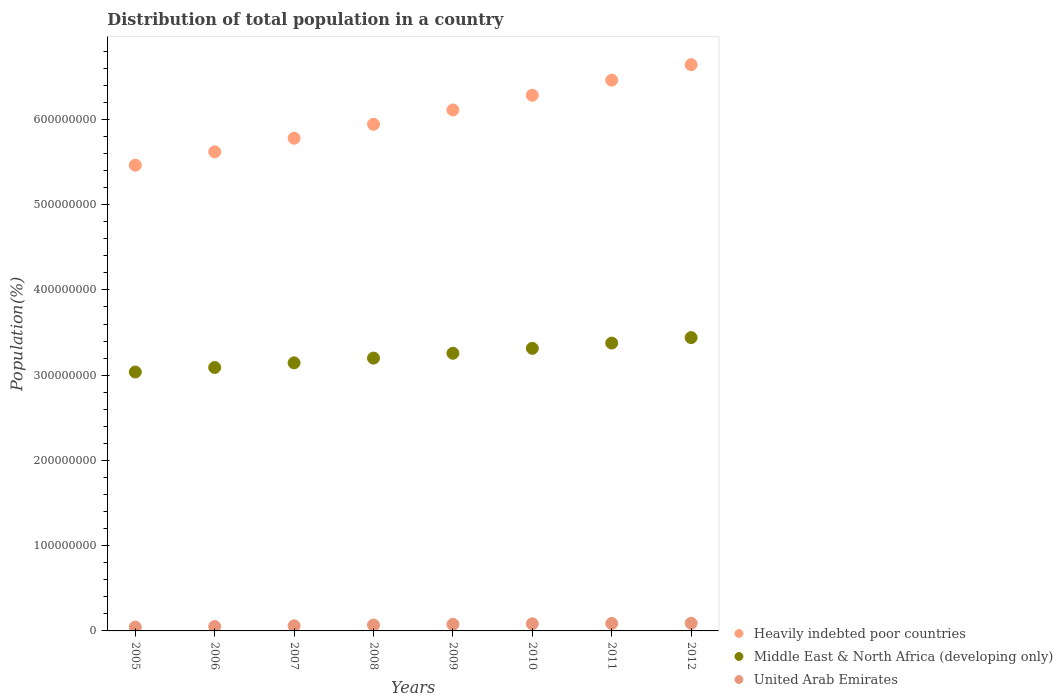What is the population of in Heavily indebted poor countries in 2005?
Provide a short and direct response. 5.46e+08. Across all years, what is the maximum population of in Middle East & North Africa (developing only)?
Give a very brief answer. 3.44e+08. Across all years, what is the minimum population of in Heavily indebted poor countries?
Provide a succinct answer. 5.46e+08. In which year was the population of in United Arab Emirates maximum?
Your response must be concise. 2012. What is the total population of in Heavily indebted poor countries in the graph?
Offer a terse response. 4.83e+09. What is the difference between the population of in United Arab Emirates in 2008 and that in 2011?
Give a very brief answer. -1.83e+06. What is the difference between the population of in Middle East & North Africa (developing only) in 2012 and the population of in United Arab Emirates in 2007?
Offer a very short reply. 3.38e+08. What is the average population of in Middle East & North Africa (developing only) per year?
Keep it short and to the point. 3.23e+08. In the year 2005, what is the difference between the population of in Heavily indebted poor countries and population of in United Arab Emirates?
Keep it short and to the point. 5.42e+08. In how many years, is the population of in Middle East & North Africa (developing only) greater than 220000000 %?
Ensure brevity in your answer.  8. What is the ratio of the population of in Heavily indebted poor countries in 2005 to that in 2009?
Provide a succinct answer. 0.89. What is the difference between the highest and the second highest population of in United Arab Emirates?
Keep it short and to the point. 2.18e+05. What is the difference between the highest and the lowest population of in Middle East & North Africa (developing only)?
Your response must be concise. 4.04e+07. In how many years, is the population of in Heavily indebted poor countries greater than the average population of in Heavily indebted poor countries taken over all years?
Make the answer very short. 4. Is the population of in United Arab Emirates strictly less than the population of in Heavily indebted poor countries over the years?
Keep it short and to the point. Yes. How many dotlines are there?
Keep it short and to the point. 3. How many years are there in the graph?
Your response must be concise. 8. What is the difference between two consecutive major ticks on the Y-axis?
Ensure brevity in your answer.  1.00e+08. Are the values on the major ticks of Y-axis written in scientific E-notation?
Give a very brief answer. No. Does the graph contain any zero values?
Keep it short and to the point. No. Does the graph contain grids?
Provide a succinct answer. No. Where does the legend appear in the graph?
Offer a very short reply. Bottom right. How many legend labels are there?
Offer a very short reply. 3. What is the title of the graph?
Your answer should be very brief. Distribution of total population in a country. What is the label or title of the X-axis?
Your answer should be compact. Years. What is the label or title of the Y-axis?
Your response must be concise. Population(%). What is the Population(%) of Heavily indebted poor countries in 2005?
Make the answer very short. 5.46e+08. What is the Population(%) in Middle East & North Africa (developing only) in 2005?
Your answer should be compact. 3.04e+08. What is the Population(%) in United Arab Emirates in 2005?
Your answer should be very brief. 4.48e+06. What is the Population(%) in Heavily indebted poor countries in 2006?
Give a very brief answer. 5.62e+08. What is the Population(%) in Middle East & North Africa (developing only) in 2006?
Your answer should be very brief. 3.09e+08. What is the Population(%) in United Arab Emirates in 2006?
Your response must be concise. 5.17e+06. What is the Population(%) in Heavily indebted poor countries in 2007?
Ensure brevity in your answer.  5.78e+08. What is the Population(%) of Middle East & North Africa (developing only) in 2007?
Provide a succinct answer. 3.14e+08. What is the Population(%) in United Arab Emirates in 2007?
Provide a short and direct response. 6.01e+06. What is the Population(%) of Heavily indebted poor countries in 2008?
Ensure brevity in your answer.  5.94e+08. What is the Population(%) in Middle East & North Africa (developing only) in 2008?
Your answer should be very brief. 3.20e+08. What is the Population(%) of United Arab Emirates in 2008?
Your response must be concise. 6.90e+06. What is the Population(%) in Heavily indebted poor countries in 2009?
Make the answer very short. 6.11e+08. What is the Population(%) of Middle East & North Africa (developing only) in 2009?
Provide a short and direct response. 3.26e+08. What is the Population(%) in United Arab Emirates in 2009?
Give a very brief answer. 7.71e+06. What is the Population(%) of Heavily indebted poor countries in 2010?
Offer a very short reply. 6.28e+08. What is the Population(%) in Middle East & North Africa (developing only) in 2010?
Offer a very short reply. 3.31e+08. What is the Population(%) of United Arab Emirates in 2010?
Your answer should be very brief. 8.33e+06. What is the Population(%) of Heavily indebted poor countries in 2011?
Offer a terse response. 6.46e+08. What is the Population(%) in Middle East & North Africa (developing only) in 2011?
Keep it short and to the point. 3.38e+08. What is the Population(%) of United Arab Emirates in 2011?
Your answer should be compact. 8.73e+06. What is the Population(%) in Heavily indebted poor countries in 2012?
Your response must be concise. 6.64e+08. What is the Population(%) in Middle East & North Africa (developing only) in 2012?
Your response must be concise. 3.44e+08. What is the Population(%) in United Arab Emirates in 2012?
Provide a succinct answer. 8.95e+06. Across all years, what is the maximum Population(%) of Heavily indebted poor countries?
Provide a succinct answer. 6.64e+08. Across all years, what is the maximum Population(%) in Middle East & North Africa (developing only)?
Provide a succinct answer. 3.44e+08. Across all years, what is the maximum Population(%) of United Arab Emirates?
Provide a succinct answer. 8.95e+06. Across all years, what is the minimum Population(%) in Heavily indebted poor countries?
Provide a succinct answer. 5.46e+08. Across all years, what is the minimum Population(%) of Middle East & North Africa (developing only)?
Provide a short and direct response. 3.04e+08. Across all years, what is the minimum Population(%) in United Arab Emirates?
Your response must be concise. 4.48e+06. What is the total Population(%) of Heavily indebted poor countries in the graph?
Keep it short and to the point. 4.83e+09. What is the total Population(%) of Middle East & North Africa (developing only) in the graph?
Offer a terse response. 2.59e+09. What is the total Population(%) of United Arab Emirates in the graph?
Your answer should be compact. 5.63e+07. What is the difference between the Population(%) in Heavily indebted poor countries in 2005 and that in 2006?
Make the answer very short. -1.56e+07. What is the difference between the Population(%) of Middle East & North Africa (developing only) in 2005 and that in 2006?
Offer a very short reply. -5.30e+06. What is the difference between the Population(%) in United Arab Emirates in 2005 and that in 2006?
Ensure brevity in your answer.  -6.89e+05. What is the difference between the Population(%) in Heavily indebted poor countries in 2005 and that in 2007?
Ensure brevity in your answer.  -3.16e+07. What is the difference between the Population(%) of Middle East & North Africa (developing only) in 2005 and that in 2007?
Your answer should be compact. -1.07e+07. What is the difference between the Population(%) of United Arab Emirates in 2005 and that in 2007?
Offer a very short reply. -1.53e+06. What is the difference between the Population(%) in Heavily indebted poor countries in 2005 and that in 2008?
Provide a succinct answer. -4.80e+07. What is the difference between the Population(%) in Middle East & North Africa (developing only) in 2005 and that in 2008?
Your answer should be very brief. -1.63e+07. What is the difference between the Population(%) in United Arab Emirates in 2005 and that in 2008?
Offer a very short reply. -2.42e+06. What is the difference between the Population(%) in Heavily indebted poor countries in 2005 and that in 2009?
Offer a very short reply. -6.48e+07. What is the difference between the Population(%) of Middle East & North Africa (developing only) in 2005 and that in 2009?
Offer a very short reply. -2.20e+07. What is the difference between the Population(%) of United Arab Emirates in 2005 and that in 2009?
Provide a succinct answer. -3.22e+06. What is the difference between the Population(%) of Heavily indebted poor countries in 2005 and that in 2010?
Make the answer very short. -8.20e+07. What is the difference between the Population(%) in Middle East & North Africa (developing only) in 2005 and that in 2010?
Make the answer very short. -2.78e+07. What is the difference between the Population(%) of United Arab Emirates in 2005 and that in 2010?
Keep it short and to the point. -3.85e+06. What is the difference between the Population(%) in Heavily indebted poor countries in 2005 and that in 2011?
Offer a terse response. -9.97e+07. What is the difference between the Population(%) in Middle East & North Africa (developing only) in 2005 and that in 2011?
Your answer should be very brief. -3.39e+07. What is the difference between the Population(%) of United Arab Emirates in 2005 and that in 2011?
Your answer should be very brief. -4.25e+06. What is the difference between the Population(%) in Heavily indebted poor countries in 2005 and that in 2012?
Ensure brevity in your answer.  -1.18e+08. What is the difference between the Population(%) of Middle East & North Africa (developing only) in 2005 and that in 2012?
Keep it short and to the point. -4.04e+07. What is the difference between the Population(%) in United Arab Emirates in 2005 and that in 2012?
Keep it short and to the point. -4.47e+06. What is the difference between the Population(%) in Heavily indebted poor countries in 2006 and that in 2007?
Your answer should be compact. -1.60e+07. What is the difference between the Population(%) of Middle East & North Africa (developing only) in 2006 and that in 2007?
Give a very brief answer. -5.43e+06. What is the difference between the Population(%) of United Arab Emirates in 2006 and that in 2007?
Offer a very short reply. -8.39e+05. What is the difference between the Population(%) in Heavily indebted poor countries in 2006 and that in 2008?
Offer a terse response. -3.24e+07. What is the difference between the Population(%) in Middle East & North Africa (developing only) in 2006 and that in 2008?
Offer a very short reply. -1.10e+07. What is the difference between the Population(%) of United Arab Emirates in 2006 and that in 2008?
Make the answer very short. -1.73e+06. What is the difference between the Population(%) in Heavily indebted poor countries in 2006 and that in 2009?
Give a very brief answer. -4.92e+07. What is the difference between the Population(%) in Middle East & North Africa (developing only) in 2006 and that in 2009?
Give a very brief answer. -1.67e+07. What is the difference between the Population(%) of United Arab Emirates in 2006 and that in 2009?
Provide a short and direct response. -2.53e+06. What is the difference between the Population(%) in Heavily indebted poor countries in 2006 and that in 2010?
Give a very brief answer. -6.64e+07. What is the difference between the Population(%) in Middle East & North Africa (developing only) in 2006 and that in 2010?
Make the answer very short. -2.25e+07. What is the difference between the Population(%) of United Arab Emirates in 2006 and that in 2010?
Make the answer very short. -3.16e+06. What is the difference between the Population(%) in Heavily indebted poor countries in 2006 and that in 2011?
Your answer should be very brief. -8.41e+07. What is the difference between the Population(%) in Middle East & North Africa (developing only) in 2006 and that in 2011?
Provide a succinct answer. -2.86e+07. What is the difference between the Population(%) of United Arab Emirates in 2006 and that in 2011?
Ensure brevity in your answer.  -3.56e+06. What is the difference between the Population(%) of Heavily indebted poor countries in 2006 and that in 2012?
Provide a short and direct response. -1.02e+08. What is the difference between the Population(%) of Middle East & North Africa (developing only) in 2006 and that in 2012?
Give a very brief answer. -3.51e+07. What is the difference between the Population(%) in United Arab Emirates in 2006 and that in 2012?
Ensure brevity in your answer.  -3.78e+06. What is the difference between the Population(%) in Heavily indebted poor countries in 2007 and that in 2008?
Give a very brief answer. -1.64e+07. What is the difference between the Population(%) in Middle East & North Africa (developing only) in 2007 and that in 2008?
Provide a short and direct response. -5.57e+06. What is the difference between the Population(%) of United Arab Emirates in 2007 and that in 2008?
Your answer should be very brief. -8.90e+05. What is the difference between the Population(%) of Heavily indebted poor countries in 2007 and that in 2009?
Provide a succinct answer. -3.32e+07. What is the difference between the Population(%) of Middle East & North Africa (developing only) in 2007 and that in 2009?
Make the answer very short. -1.13e+07. What is the difference between the Population(%) of United Arab Emirates in 2007 and that in 2009?
Provide a succinct answer. -1.70e+06. What is the difference between the Population(%) in Heavily indebted poor countries in 2007 and that in 2010?
Keep it short and to the point. -5.04e+07. What is the difference between the Population(%) in Middle East & North Africa (developing only) in 2007 and that in 2010?
Give a very brief answer. -1.70e+07. What is the difference between the Population(%) of United Arab Emirates in 2007 and that in 2010?
Offer a very short reply. -2.32e+06. What is the difference between the Population(%) of Heavily indebted poor countries in 2007 and that in 2011?
Offer a very short reply. -6.81e+07. What is the difference between the Population(%) of Middle East & North Africa (developing only) in 2007 and that in 2011?
Keep it short and to the point. -2.32e+07. What is the difference between the Population(%) in United Arab Emirates in 2007 and that in 2011?
Offer a terse response. -2.72e+06. What is the difference between the Population(%) of Heavily indebted poor countries in 2007 and that in 2012?
Your answer should be very brief. -8.62e+07. What is the difference between the Population(%) of Middle East & North Africa (developing only) in 2007 and that in 2012?
Provide a short and direct response. -2.96e+07. What is the difference between the Population(%) in United Arab Emirates in 2007 and that in 2012?
Keep it short and to the point. -2.94e+06. What is the difference between the Population(%) in Heavily indebted poor countries in 2008 and that in 2009?
Your answer should be very brief. -1.68e+07. What is the difference between the Population(%) in Middle East & North Africa (developing only) in 2008 and that in 2009?
Provide a short and direct response. -5.68e+06. What is the difference between the Population(%) in United Arab Emirates in 2008 and that in 2009?
Provide a succinct answer. -8.05e+05. What is the difference between the Population(%) of Heavily indebted poor countries in 2008 and that in 2010?
Your answer should be very brief. -3.40e+07. What is the difference between the Population(%) in Middle East & North Africa (developing only) in 2008 and that in 2010?
Ensure brevity in your answer.  -1.15e+07. What is the difference between the Population(%) of United Arab Emirates in 2008 and that in 2010?
Keep it short and to the point. -1.43e+06. What is the difference between the Population(%) in Heavily indebted poor countries in 2008 and that in 2011?
Provide a short and direct response. -5.17e+07. What is the difference between the Population(%) in Middle East & North Africa (developing only) in 2008 and that in 2011?
Your answer should be very brief. -1.76e+07. What is the difference between the Population(%) in United Arab Emirates in 2008 and that in 2011?
Provide a short and direct response. -1.83e+06. What is the difference between the Population(%) of Heavily indebted poor countries in 2008 and that in 2012?
Your answer should be very brief. -6.99e+07. What is the difference between the Population(%) in Middle East & North Africa (developing only) in 2008 and that in 2012?
Your answer should be compact. -2.40e+07. What is the difference between the Population(%) of United Arab Emirates in 2008 and that in 2012?
Your answer should be compact. -2.05e+06. What is the difference between the Population(%) of Heavily indebted poor countries in 2009 and that in 2010?
Provide a succinct answer. -1.72e+07. What is the difference between the Population(%) of Middle East & North Africa (developing only) in 2009 and that in 2010?
Provide a short and direct response. -5.77e+06. What is the difference between the Population(%) of United Arab Emirates in 2009 and that in 2010?
Make the answer very short. -6.24e+05. What is the difference between the Population(%) of Heavily indebted poor countries in 2009 and that in 2011?
Your response must be concise. -3.49e+07. What is the difference between the Population(%) of Middle East & North Africa (developing only) in 2009 and that in 2011?
Your response must be concise. -1.19e+07. What is the difference between the Population(%) of United Arab Emirates in 2009 and that in 2011?
Offer a terse response. -1.03e+06. What is the difference between the Population(%) of Heavily indebted poor countries in 2009 and that in 2012?
Provide a succinct answer. -5.31e+07. What is the difference between the Population(%) in Middle East & North Africa (developing only) in 2009 and that in 2012?
Ensure brevity in your answer.  -1.84e+07. What is the difference between the Population(%) of United Arab Emirates in 2009 and that in 2012?
Give a very brief answer. -1.25e+06. What is the difference between the Population(%) in Heavily indebted poor countries in 2010 and that in 2011?
Provide a short and direct response. -1.77e+07. What is the difference between the Population(%) in Middle East & North Africa (developing only) in 2010 and that in 2011?
Ensure brevity in your answer.  -6.18e+06. What is the difference between the Population(%) in United Arab Emirates in 2010 and that in 2011?
Make the answer very short. -4.05e+05. What is the difference between the Population(%) in Heavily indebted poor countries in 2010 and that in 2012?
Your answer should be very brief. -3.58e+07. What is the difference between the Population(%) in Middle East & North Africa (developing only) in 2010 and that in 2012?
Your answer should be very brief. -1.26e+07. What is the difference between the Population(%) of United Arab Emirates in 2010 and that in 2012?
Offer a very short reply. -6.23e+05. What is the difference between the Population(%) of Heavily indebted poor countries in 2011 and that in 2012?
Give a very brief answer. -1.81e+07. What is the difference between the Population(%) of Middle East & North Africa (developing only) in 2011 and that in 2012?
Offer a very short reply. -6.41e+06. What is the difference between the Population(%) in United Arab Emirates in 2011 and that in 2012?
Keep it short and to the point. -2.18e+05. What is the difference between the Population(%) of Heavily indebted poor countries in 2005 and the Population(%) of Middle East & North Africa (developing only) in 2006?
Make the answer very short. 2.37e+08. What is the difference between the Population(%) of Heavily indebted poor countries in 2005 and the Population(%) of United Arab Emirates in 2006?
Your response must be concise. 5.41e+08. What is the difference between the Population(%) of Middle East & North Africa (developing only) in 2005 and the Population(%) of United Arab Emirates in 2006?
Give a very brief answer. 2.99e+08. What is the difference between the Population(%) in Heavily indebted poor countries in 2005 and the Population(%) in Middle East & North Africa (developing only) in 2007?
Offer a terse response. 2.32e+08. What is the difference between the Population(%) of Heavily indebted poor countries in 2005 and the Population(%) of United Arab Emirates in 2007?
Your answer should be very brief. 5.40e+08. What is the difference between the Population(%) of Middle East & North Africa (developing only) in 2005 and the Population(%) of United Arab Emirates in 2007?
Offer a terse response. 2.98e+08. What is the difference between the Population(%) in Heavily indebted poor countries in 2005 and the Population(%) in Middle East & North Africa (developing only) in 2008?
Ensure brevity in your answer.  2.26e+08. What is the difference between the Population(%) in Heavily indebted poor countries in 2005 and the Population(%) in United Arab Emirates in 2008?
Give a very brief answer. 5.39e+08. What is the difference between the Population(%) of Middle East & North Africa (developing only) in 2005 and the Population(%) of United Arab Emirates in 2008?
Ensure brevity in your answer.  2.97e+08. What is the difference between the Population(%) of Heavily indebted poor countries in 2005 and the Population(%) of Middle East & North Africa (developing only) in 2009?
Offer a very short reply. 2.21e+08. What is the difference between the Population(%) in Heavily indebted poor countries in 2005 and the Population(%) in United Arab Emirates in 2009?
Your answer should be very brief. 5.39e+08. What is the difference between the Population(%) of Middle East & North Africa (developing only) in 2005 and the Population(%) of United Arab Emirates in 2009?
Give a very brief answer. 2.96e+08. What is the difference between the Population(%) in Heavily indebted poor countries in 2005 and the Population(%) in Middle East & North Africa (developing only) in 2010?
Make the answer very short. 2.15e+08. What is the difference between the Population(%) of Heavily indebted poor countries in 2005 and the Population(%) of United Arab Emirates in 2010?
Provide a short and direct response. 5.38e+08. What is the difference between the Population(%) in Middle East & North Africa (developing only) in 2005 and the Population(%) in United Arab Emirates in 2010?
Make the answer very short. 2.95e+08. What is the difference between the Population(%) in Heavily indebted poor countries in 2005 and the Population(%) in Middle East & North Africa (developing only) in 2011?
Your answer should be very brief. 2.09e+08. What is the difference between the Population(%) of Heavily indebted poor countries in 2005 and the Population(%) of United Arab Emirates in 2011?
Your response must be concise. 5.38e+08. What is the difference between the Population(%) in Middle East & North Africa (developing only) in 2005 and the Population(%) in United Arab Emirates in 2011?
Your response must be concise. 2.95e+08. What is the difference between the Population(%) of Heavily indebted poor countries in 2005 and the Population(%) of Middle East & North Africa (developing only) in 2012?
Provide a succinct answer. 2.02e+08. What is the difference between the Population(%) of Heavily indebted poor countries in 2005 and the Population(%) of United Arab Emirates in 2012?
Your response must be concise. 5.37e+08. What is the difference between the Population(%) in Middle East & North Africa (developing only) in 2005 and the Population(%) in United Arab Emirates in 2012?
Your answer should be compact. 2.95e+08. What is the difference between the Population(%) in Heavily indebted poor countries in 2006 and the Population(%) in Middle East & North Africa (developing only) in 2007?
Keep it short and to the point. 2.48e+08. What is the difference between the Population(%) of Heavily indebted poor countries in 2006 and the Population(%) of United Arab Emirates in 2007?
Your answer should be very brief. 5.56e+08. What is the difference between the Population(%) of Middle East & North Africa (developing only) in 2006 and the Population(%) of United Arab Emirates in 2007?
Provide a succinct answer. 3.03e+08. What is the difference between the Population(%) of Heavily indebted poor countries in 2006 and the Population(%) of Middle East & North Africa (developing only) in 2008?
Your answer should be very brief. 2.42e+08. What is the difference between the Population(%) in Heavily indebted poor countries in 2006 and the Population(%) in United Arab Emirates in 2008?
Offer a very short reply. 5.55e+08. What is the difference between the Population(%) in Middle East & North Africa (developing only) in 2006 and the Population(%) in United Arab Emirates in 2008?
Make the answer very short. 3.02e+08. What is the difference between the Population(%) of Heavily indebted poor countries in 2006 and the Population(%) of Middle East & North Africa (developing only) in 2009?
Your answer should be very brief. 2.36e+08. What is the difference between the Population(%) in Heavily indebted poor countries in 2006 and the Population(%) in United Arab Emirates in 2009?
Your answer should be compact. 5.54e+08. What is the difference between the Population(%) in Middle East & North Africa (developing only) in 2006 and the Population(%) in United Arab Emirates in 2009?
Provide a short and direct response. 3.01e+08. What is the difference between the Population(%) in Heavily indebted poor countries in 2006 and the Population(%) in Middle East & North Africa (developing only) in 2010?
Keep it short and to the point. 2.30e+08. What is the difference between the Population(%) of Heavily indebted poor countries in 2006 and the Population(%) of United Arab Emirates in 2010?
Offer a very short reply. 5.54e+08. What is the difference between the Population(%) of Middle East & North Africa (developing only) in 2006 and the Population(%) of United Arab Emirates in 2010?
Offer a terse response. 3.01e+08. What is the difference between the Population(%) in Heavily indebted poor countries in 2006 and the Population(%) in Middle East & North Africa (developing only) in 2011?
Your answer should be compact. 2.24e+08. What is the difference between the Population(%) of Heavily indebted poor countries in 2006 and the Population(%) of United Arab Emirates in 2011?
Offer a very short reply. 5.53e+08. What is the difference between the Population(%) of Middle East & North Africa (developing only) in 2006 and the Population(%) of United Arab Emirates in 2011?
Your answer should be compact. 3.00e+08. What is the difference between the Population(%) of Heavily indebted poor countries in 2006 and the Population(%) of Middle East & North Africa (developing only) in 2012?
Offer a very short reply. 2.18e+08. What is the difference between the Population(%) of Heavily indebted poor countries in 2006 and the Population(%) of United Arab Emirates in 2012?
Your answer should be very brief. 5.53e+08. What is the difference between the Population(%) in Middle East & North Africa (developing only) in 2006 and the Population(%) in United Arab Emirates in 2012?
Offer a very short reply. 3.00e+08. What is the difference between the Population(%) of Heavily indebted poor countries in 2007 and the Population(%) of Middle East & North Africa (developing only) in 2008?
Offer a very short reply. 2.58e+08. What is the difference between the Population(%) of Heavily indebted poor countries in 2007 and the Population(%) of United Arab Emirates in 2008?
Your answer should be very brief. 5.71e+08. What is the difference between the Population(%) of Middle East & North Africa (developing only) in 2007 and the Population(%) of United Arab Emirates in 2008?
Your answer should be very brief. 3.08e+08. What is the difference between the Population(%) in Heavily indebted poor countries in 2007 and the Population(%) in Middle East & North Africa (developing only) in 2009?
Offer a very short reply. 2.52e+08. What is the difference between the Population(%) of Heavily indebted poor countries in 2007 and the Population(%) of United Arab Emirates in 2009?
Provide a short and direct response. 5.70e+08. What is the difference between the Population(%) of Middle East & North Africa (developing only) in 2007 and the Population(%) of United Arab Emirates in 2009?
Offer a terse response. 3.07e+08. What is the difference between the Population(%) in Heavily indebted poor countries in 2007 and the Population(%) in Middle East & North Africa (developing only) in 2010?
Give a very brief answer. 2.46e+08. What is the difference between the Population(%) of Heavily indebted poor countries in 2007 and the Population(%) of United Arab Emirates in 2010?
Make the answer very short. 5.70e+08. What is the difference between the Population(%) in Middle East & North Africa (developing only) in 2007 and the Population(%) in United Arab Emirates in 2010?
Provide a short and direct response. 3.06e+08. What is the difference between the Population(%) in Heavily indebted poor countries in 2007 and the Population(%) in Middle East & North Africa (developing only) in 2011?
Ensure brevity in your answer.  2.40e+08. What is the difference between the Population(%) of Heavily indebted poor countries in 2007 and the Population(%) of United Arab Emirates in 2011?
Ensure brevity in your answer.  5.69e+08. What is the difference between the Population(%) of Middle East & North Africa (developing only) in 2007 and the Population(%) of United Arab Emirates in 2011?
Your answer should be compact. 3.06e+08. What is the difference between the Population(%) in Heavily indebted poor countries in 2007 and the Population(%) in Middle East & North Africa (developing only) in 2012?
Offer a terse response. 2.34e+08. What is the difference between the Population(%) of Heavily indebted poor countries in 2007 and the Population(%) of United Arab Emirates in 2012?
Give a very brief answer. 5.69e+08. What is the difference between the Population(%) of Middle East & North Africa (developing only) in 2007 and the Population(%) of United Arab Emirates in 2012?
Ensure brevity in your answer.  3.05e+08. What is the difference between the Population(%) of Heavily indebted poor countries in 2008 and the Population(%) of Middle East & North Africa (developing only) in 2009?
Your answer should be very brief. 2.69e+08. What is the difference between the Population(%) of Heavily indebted poor countries in 2008 and the Population(%) of United Arab Emirates in 2009?
Keep it short and to the point. 5.87e+08. What is the difference between the Population(%) of Middle East & North Africa (developing only) in 2008 and the Population(%) of United Arab Emirates in 2009?
Offer a terse response. 3.12e+08. What is the difference between the Population(%) in Heavily indebted poor countries in 2008 and the Population(%) in Middle East & North Africa (developing only) in 2010?
Give a very brief answer. 2.63e+08. What is the difference between the Population(%) in Heavily indebted poor countries in 2008 and the Population(%) in United Arab Emirates in 2010?
Keep it short and to the point. 5.86e+08. What is the difference between the Population(%) in Middle East & North Africa (developing only) in 2008 and the Population(%) in United Arab Emirates in 2010?
Provide a short and direct response. 3.12e+08. What is the difference between the Population(%) of Heavily indebted poor countries in 2008 and the Population(%) of Middle East & North Africa (developing only) in 2011?
Provide a short and direct response. 2.57e+08. What is the difference between the Population(%) of Heavily indebted poor countries in 2008 and the Population(%) of United Arab Emirates in 2011?
Give a very brief answer. 5.86e+08. What is the difference between the Population(%) of Middle East & North Africa (developing only) in 2008 and the Population(%) of United Arab Emirates in 2011?
Make the answer very short. 3.11e+08. What is the difference between the Population(%) in Heavily indebted poor countries in 2008 and the Population(%) in Middle East & North Africa (developing only) in 2012?
Your answer should be compact. 2.50e+08. What is the difference between the Population(%) in Heavily indebted poor countries in 2008 and the Population(%) in United Arab Emirates in 2012?
Offer a terse response. 5.85e+08. What is the difference between the Population(%) of Middle East & North Africa (developing only) in 2008 and the Population(%) of United Arab Emirates in 2012?
Make the answer very short. 3.11e+08. What is the difference between the Population(%) in Heavily indebted poor countries in 2009 and the Population(%) in Middle East & North Africa (developing only) in 2010?
Your answer should be very brief. 2.80e+08. What is the difference between the Population(%) in Heavily indebted poor countries in 2009 and the Population(%) in United Arab Emirates in 2010?
Give a very brief answer. 6.03e+08. What is the difference between the Population(%) of Middle East & North Africa (developing only) in 2009 and the Population(%) of United Arab Emirates in 2010?
Your answer should be compact. 3.17e+08. What is the difference between the Population(%) of Heavily indebted poor countries in 2009 and the Population(%) of Middle East & North Africa (developing only) in 2011?
Your answer should be compact. 2.73e+08. What is the difference between the Population(%) in Heavily indebted poor countries in 2009 and the Population(%) in United Arab Emirates in 2011?
Your response must be concise. 6.02e+08. What is the difference between the Population(%) of Middle East & North Africa (developing only) in 2009 and the Population(%) of United Arab Emirates in 2011?
Your answer should be compact. 3.17e+08. What is the difference between the Population(%) in Heavily indebted poor countries in 2009 and the Population(%) in Middle East & North Africa (developing only) in 2012?
Offer a very short reply. 2.67e+08. What is the difference between the Population(%) in Heavily indebted poor countries in 2009 and the Population(%) in United Arab Emirates in 2012?
Give a very brief answer. 6.02e+08. What is the difference between the Population(%) of Middle East & North Africa (developing only) in 2009 and the Population(%) of United Arab Emirates in 2012?
Provide a short and direct response. 3.17e+08. What is the difference between the Population(%) in Heavily indebted poor countries in 2010 and the Population(%) in Middle East & North Africa (developing only) in 2011?
Ensure brevity in your answer.  2.91e+08. What is the difference between the Population(%) in Heavily indebted poor countries in 2010 and the Population(%) in United Arab Emirates in 2011?
Give a very brief answer. 6.20e+08. What is the difference between the Population(%) of Middle East & North Africa (developing only) in 2010 and the Population(%) of United Arab Emirates in 2011?
Your answer should be compact. 3.23e+08. What is the difference between the Population(%) of Heavily indebted poor countries in 2010 and the Population(%) of Middle East & North Africa (developing only) in 2012?
Provide a short and direct response. 2.84e+08. What is the difference between the Population(%) of Heavily indebted poor countries in 2010 and the Population(%) of United Arab Emirates in 2012?
Give a very brief answer. 6.19e+08. What is the difference between the Population(%) of Middle East & North Africa (developing only) in 2010 and the Population(%) of United Arab Emirates in 2012?
Keep it short and to the point. 3.23e+08. What is the difference between the Population(%) in Heavily indebted poor countries in 2011 and the Population(%) in Middle East & North Africa (developing only) in 2012?
Offer a very short reply. 3.02e+08. What is the difference between the Population(%) of Heavily indebted poor countries in 2011 and the Population(%) of United Arab Emirates in 2012?
Provide a succinct answer. 6.37e+08. What is the difference between the Population(%) of Middle East & North Africa (developing only) in 2011 and the Population(%) of United Arab Emirates in 2012?
Offer a very short reply. 3.29e+08. What is the average Population(%) of Heavily indebted poor countries per year?
Your response must be concise. 6.04e+08. What is the average Population(%) of Middle East & North Africa (developing only) per year?
Keep it short and to the point. 3.23e+08. What is the average Population(%) in United Arab Emirates per year?
Your answer should be compact. 7.04e+06. In the year 2005, what is the difference between the Population(%) in Heavily indebted poor countries and Population(%) in Middle East & North Africa (developing only)?
Your answer should be compact. 2.43e+08. In the year 2005, what is the difference between the Population(%) of Heavily indebted poor countries and Population(%) of United Arab Emirates?
Provide a succinct answer. 5.42e+08. In the year 2005, what is the difference between the Population(%) of Middle East & North Africa (developing only) and Population(%) of United Arab Emirates?
Offer a terse response. 2.99e+08. In the year 2006, what is the difference between the Population(%) of Heavily indebted poor countries and Population(%) of Middle East & North Africa (developing only)?
Keep it short and to the point. 2.53e+08. In the year 2006, what is the difference between the Population(%) in Heavily indebted poor countries and Population(%) in United Arab Emirates?
Make the answer very short. 5.57e+08. In the year 2006, what is the difference between the Population(%) of Middle East & North Africa (developing only) and Population(%) of United Arab Emirates?
Provide a short and direct response. 3.04e+08. In the year 2007, what is the difference between the Population(%) of Heavily indebted poor countries and Population(%) of Middle East & North Africa (developing only)?
Offer a terse response. 2.63e+08. In the year 2007, what is the difference between the Population(%) of Heavily indebted poor countries and Population(%) of United Arab Emirates?
Provide a short and direct response. 5.72e+08. In the year 2007, what is the difference between the Population(%) in Middle East & North Africa (developing only) and Population(%) in United Arab Emirates?
Your answer should be very brief. 3.08e+08. In the year 2008, what is the difference between the Population(%) in Heavily indebted poor countries and Population(%) in Middle East & North Africa (developing only)?
Keep it short and to the point. 2.74e+08. In the year 2008, what is the difference between the Population(%) of Heavily indebted poor countries and Population(%) of United Arab Emirates?
Ensure brevity in your answer.  5.87e+08. In the year 2008, what is the difference between the Population(%) of Middle East & North Africa (developing only) and Population(%) of United Arab Emirates?
Your answer should be compact. 3.13e+08. In the year 2009, what is the difference between the Population(%) in Heavily indebted poor countries and Population(%) in Middle East & North Africa (developing only)?
Your answer should be compact. 2.85e+08. In the year 2009, what is the difference between the Population(%) in Heavily indebted poor countries and Population(%) in United Arab Emirates?
Your response must be concise. 6.03e+08. In the year 2009, what is the difference between the Population(%) in Middle East & North Africa (developing only) and Population(%) in United Arab Emirates?
Provide a short and direct response. 3.18e+08. In the year 2010, what is the difference between the Population(%) of Heavily indebted poor countries and Population(%) of Middle East & North Africa (developing only)?
Provide a succinct answer. 2.97e+08. In the year 2010, what is the difference between the Population(%) of Heavily indebted poor countries and Population(%) of United Arab Emirates?
Offer a terse response. 6.20e+08. In the year 2010, what is the difference between the Population(%) in Middle East & North Africa (developing only) and Population(%) in United Arab Emirates?
Your answer should be very brief. 3.23e+08. In the year 2011, what is the difference between the Population(%) in Heavily indebted poor countries and Population(%) in Middle East & North Africa (developing only)?
Offer a very short reply. 3.08e+08. In the year 2011, what is the difference between the Population(%) in Heavily indebted poor countries and Population(%) in United Arab Emirates?
Your response must be concise. 6.37e+08. In the year 2011, what is the difference between the Population(%) in Middle East & North Africa (developing only) and Population(%) in United Arab Emirates?
Your response must be concise. 3.29e+08. In the year 2012, what is the difference between the Population(%) of Heavily indebted poor countries and Population(%) of Middle East & North Africa (developing only)?
Your answer should be compact. 3.20e+08. In the year 2012, what is the difference between the Population(%) of Heavily indebted poor countries and Population(%) of United Arab Emirates?
Your answer should be compact. 6.55e+08. In the year 2012, what is the difference between the Population(%) in Middle East & North Africa (developing only) and Population(%) in United Arab Emirates?
Ensure brevity in your answer.  3.35e+08. What is the ratio of the Population(%) in Heavily indebted poor countries in 2005 to that in 2006?
Your answer should be compact. 0.97. What is the ratio of the Population(%) in Middle East & North Africa (developing only) in 2005 to that in 2006?
Your answer should be very brief. 0.98. What is the ratio of the Population(%) in United Arab Emirates in 2005 to that in 2006?
Your answer should be very brief. 0.87. What is the ratio of the Population(%) in Heavily indebted poor countries in 2005 to that in 2007?
Offer a terse response. 0.95. What is the ratio of the Population(%) of Middle East & North Africa (developing only) in 2005 to that in 2007?
Offer a terse response. 0.97. What is the ratio of the Population(%) in United Arab Emirates in 2005 to that in 2007?
Provide a short and direct response. 0.75. What is the ratio of the Population(%) of Heavily indebted poor countries in 2005 to that in 2008?
Offer a very short reply. 0.92. What is the ratio of the Population(%) in Middle East & North Africa (developing only) in 2005 to that in 2008?
Offer a terse response. 0.95. What is the ratio of the Population(%) of United Arab Emirates in 2005 to that in 2008?
Offer a terse response. 0.65. What is the ratio of the Population(%) in Heavily indebted poor countries in 2005 to that in 2009?
Offer a very short reply. 0.89. What is the ratio of the Population(%) of Middle East & North Africa (developing only) in 2005 to that in 2009?
Offer a terse response. 0.93. What is the ratio of the Population(%) in United Arab Emirates in 2005 to that in 2009?
Offer a terse response. 0.58. What is the ratio of the Population(%) of Heavily indebted poor countries in 2005 to that in 2010?
Provide a short and direct response. 0.87. What is the ratio of the Population(%) in Middle East & North Africa (developing only) in 2005 to that in 2010?
Keep it short and to the point. 0.92. What is the ratio of the Population(%) of United Arab Emirates in 2005 to that in 2010?
Give a very brief answer. 0.54. What is the ratio of the Population(%) in Heavily indebted poor countries in 2005 to that in 2011?
Provide a succinct answer. 0.85. What is the ratio of the Population(%) in Middle East & North Africa (developing only) in 2005 to that in 2011?
Keep it short and to the point. 0.9. What is the ratio of the Population(%) of United Arab Emirates in 2005 to that in 2011?
Offer a very short reply. 0.51. What is the ratio of the Population(%) of Heavily indebted poor countries in 2005 to that in 2012?
Keep it short and to the point. 0.82. What is the ratio of the Population(%) in Middle East & North Africa (developing only) in 2005 to that in 2012?
Provide a succinct answer. 0.88. What is the ratio of the Population(%) in United Arab Emirates in 2005 to that in 2012?
Make the answer very short. 0.5. What is the ratio of the Population(%) in Heavily indebted poor countries in 2006 to that in 2007?
Offer a very short reply. 0.97. What is the ratio of the Population(%) of Middle East & North Africa (developing only) in 2006 to that in 2007?
Offer a terse response. 0.98. What is the ratio of the Population(%) in United Arab Emirates in 2006 to that in 2007?
Give a very brief answer. 0.86. What is the ratio of the Population(%) of Heavily indebted poor countries in 2006 to that in 2008?
Your answer should be compact. 0.95. What is the ratio of the Population(%) of Middle East & North Africa (developing only) in 2006 to that in 2008?
Ensure brevity in your answer.  0.97. What is the ratio of the Population(%) of United Arab Emirates in 2006 to that in 2008?
Make the answer very short. 0.75. What is the ratio of the Population(%) in Heavily indebted poor countries in 2006 to that in 2009?
Provide a short and direct response. 0.92. What is the ratio of the Population(%) of Middle East & North Africa (developing only) in 2006 to that in 2009?
Ensure brevity in your answer.  0.95. What is the ratio of the Population(%) of United Arab Emirates in 2006 to that in 2009?
Your answer should be very brief. 0.67. What is the ratio of the Population(%) of Heavily indebted poor countries in 2006 to that in 2010?
Provide a succinct answer. 0.89. What is the ratio of the Population(%) in Middle East & North Africa (developing only) in 2006 to that in 2010?
Provide a succinct answer. 0.93. What is the ratio of the Population(%) of United Arab Emirates in 2006 to that in 2010?
Your answer should be very brief. 0.62. What is the ratio of the Population(%) of Heavily indebted poor countries in 2006 to that in 2011?
Ensure brevity in your answer.  0.87. What is the ratio of the Population(%) in Middle East & North Africa (developing only) in 2006 to that in 2011?
Offer a very short reply. 0.92. What is the ratio of the Population(%) of United Arab Emirates in 2006 to that in 2011?
Offer a terse response. 0.59. What is the ratio of the Population(%) of Heavily indebted poor countries in 2006 to that in 2012?
Make the answer very short. 0.85. What is the ratio of the Population(%) in Middle East & North Africa (developing only) in 2006 to that in 2012?
Offer a very short reply. 0.9. What is the ratio of the Population(%) in United Arab Emirates in 2006 to that in 2012?
Provide a short and direct response. 0.58. What is the ratio of the Population(%) in Heavily indebted poor countries in 2007 to that in 2008?
Your answer should be compact. 0.97. What is the ratio of the Population(%) in Middle East & North Africa (developing only) in 2007 to that in 2008?
Offer a terse response. 0.98. What is the ratio of the Population(%) in United Arab Emirates in 2007 to that in 2008?
Your answer should be compact. 0.87. What is the ratio of the Population(%) in Heavily indebted poor countries in 2007 to that in 2009?
Your answer should be very brief. 0.95. What is the ratio of the Population(%) of Middle East & North Africa (developing only) in 2007 to that in 2009?
Your response must be concise. 0.97. What is the ratio of the Population(%) in United Arab Emirates in 2007 to that in 2009?
Offer a terse response. 0.78. What is the ratio of the Population(%) of Heavily indebted poor countries in 2007 to that in 2010?
Offer a very short reply. 0.92. What is the ratio of the Population(%) in Middle East & North Africa (developing only) in 2007 to that in 2010?
Your answer should be very brief. 0.95. What is the ratio of the Population(%) of United Arab Emirates in 2007 to that in 2010?
Provide a succinct answer. 0.72. What is the ratio of the Population(%) in Heavily indebted poor countries in 2007 to that in 2011?
Your answer should be very brief. 0.89. What is the ratio of the Population(%) in Middle East & North Africa (developing only) in 2007 to that in 2011?
Ensure brevity in your answer.  0.93. What is the ratio of the Population(%) in United Arab Emirates in 2007 to that in 2011?
Keep it short and to the point. 0.69. What is the ratio of the Population(%) in Heavily indebted poor countries in 2007 to that in 2012?
Your answer should be very brief. 0.87. What is the ratio of the Population(%) of Middle East & North Africa (developing only) in 2007 to that in 2012?
Offer a terse response. 0.91. What is the ratio of the Population(%) in United Arab Emirates in 2007 to that in 2012?
Give a very brief answer. 0.67. What is the ratio of the Population(%) in Heavily indebted poor countries in 2008 to that in 2009?
Your answer should be compact. 0.97. What is the ratio of the Population(%) of Middle East & North Africa (developing only) in 2008 to that in 2009?
Offer a terse response. 0.98. What is the ratio of the Population(%) of United Arab Emirates in 2008 to that in 2009?
Keep it short and to the point. 0.9. What is the ratio of the Population(%) in Heavily indebted poor countries in 2008 to that in 2010?
Your response must be concise. 0.95. What is the ratio of the Population(%) in Middle East & North Africa (developing only) in 2008 to that in 2010?
Your response must be concise. 0.97. What is the ratio of the Population(%) of United Arab Emirates in 2008 to that in 2010?
Ensure brevity in your answer.  0.83. What is the ratio of the Population(%) of Heavily indebted poor countries in 2008 to that in 2011?
Provide a short and direct response. 0.92. What is the ratio of the Population(%) of Middle East & North Africa (developing only) in 2008 to that in 2011?
Offer a terse response. 0.95. What is the ratio of the Population(%) of United Arab Emirates in 2008 to that in 2011?
Provide a succinct answer. 0.79. What is the ratio of the Population(%) of Heavily indebted poor countries in 2008 to that in 2012?
Offer a terse response. 0.89. What is the ratio of the Population(%) of Middle East & North Africa (developing only) in 2008 to that in 2012?
Provide a succinct answer. 0.93. What is the ratio of the Population(%) of United Arab Emirates in 2008 to that in 2012?
Your answer should be compact. 0.77. What is the ratio of the Population(%) of Heavily indebted poor countries in 2009 to that in 2010?
Offer a terse response. 0.97. What is the ratio of the Population(%) in Middle East & North Africa (developing only) in 2009 to that in 2010?
Your answer should be compact. 0.98. What is the ratio of the Population(%) of United Arab Emirates in 2009 to that in 2010?
Ensure brevity in your answer.  0.93. What is the ratio of the Population(%) in Heavily indebted poor countries in 2009 to that in 2011?
Give a very brief answer. 0.95. What is the ratio of the Population(%) in Middle East & North Africa (developing only) in 2009 to that in 2011?
Offer a very short reply. 0.96. What is the ratio of the Population(%) in United Arab Emirates in 2009 to that in 2011?
Ensure brevity in your answer.  0.88. What is the ratio of the Population(%) in Heavily indebted poor countries in 2009 to that in 2012?
Ensure brevity in your answer.  0.92. What is the ratio of the Population(%) of Middle East & North Africa (developing only) in 2009 to that in 2012?
Provide a short and direct response. 0.95. What is the ratio of the Population(%) in United Arab Emirates in 2009 to that in 2012?
Your answer should be compact. 0.86. What is the ratio of the Population(%) of Heavily indebted poor countries in 2010 to that in 2011?
Your answer should be compact. 0.97. What is the ratio of the Population(%) in Middle East & North Africa (developing only) in 2010 to that in 2011?
Give a very brief answer. 0.98. What is the ratio of the Population(%) in United Arab Emirates in 2010 to that in 2011?
Ensure brevity in your answer.  0.95. What is the ratio of the Population(%) of Heavily indebted poor countries in 2010 to that in 2012?
Keep it short and to the point. 0.95. What is the ratio of the Population(%) in Middle East & North Africa (developing only) in 2010 to that in 2012?
Your answer should be very brief. 0.96. What is the ratio of the Population(%) in United Arab Emirates in 2010 to that in 2012?
Your response must be concise. 0.93. What is the ratio of the Population(%) of Heavily indebted poor countries in 2011 to that in 2012?
Make the answer very short. 0.97. What is the ratio of the Population(%) in Middle East & North Africa (developing only) in 2011 to that in 2012?
Keep it short and to the point. 0.98. What is the ratio of the Population(%) of United Arab Emirates in 2011 to that in 2012?
Offer a very short reply. 0.98. What is the difference between the highest and the second highest Population(%) in Heavily indebted poor countries?
Offer a very short reply. 1.81e+07. What is the difference between the highest and the second highest Population(%) in Middle East & North Africa (developing only)?
Offer a very short reply. 6.41e+06. What is the difference between the highest and the second highest Population(%) in United Arab Emirates?
Ensure brevity in your answer.  2.18e+05. What is the difference between the highest and the lowest Population(%) of Heavily indebted poor countries?
Your answer should be very brief. 1.18e+08. What is the difference between the highest and the lowest Population(%) in Middle East & North Africa (developing only)?
Your answer should be compact. 4.04e+07. What is the difference between the highest and the lowest Population(%) in United Arab Emirates?
Keep it short and to the point. 4.47e+06. 